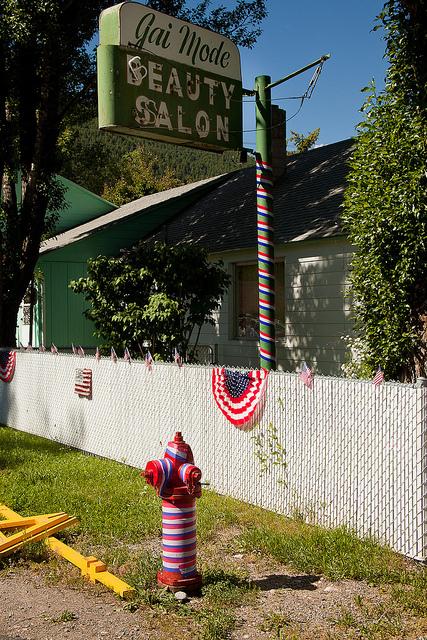Is there a fire hydrant in the picture?
Short answer required. Yes. What flag is hanging on the fence?
Keep it brief. American. What kind of business is depicted in the picture?
Keep it brief. Beauty salon. 